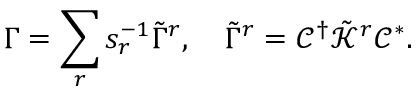<formula> <loc_0><loc_0><loc_500><loc_500>\Gamma = \sum _ { r } s _ { r } ^ { - 1 } \tilde { \Gamma } ^ { r } , \quad \tilde { \Gamma } ^ { r } = \mathcal { C } ^ { \dag } \tilde { \mathcal { K } } ^ { r } \mathcal { C } ^ { * } .</formula> 